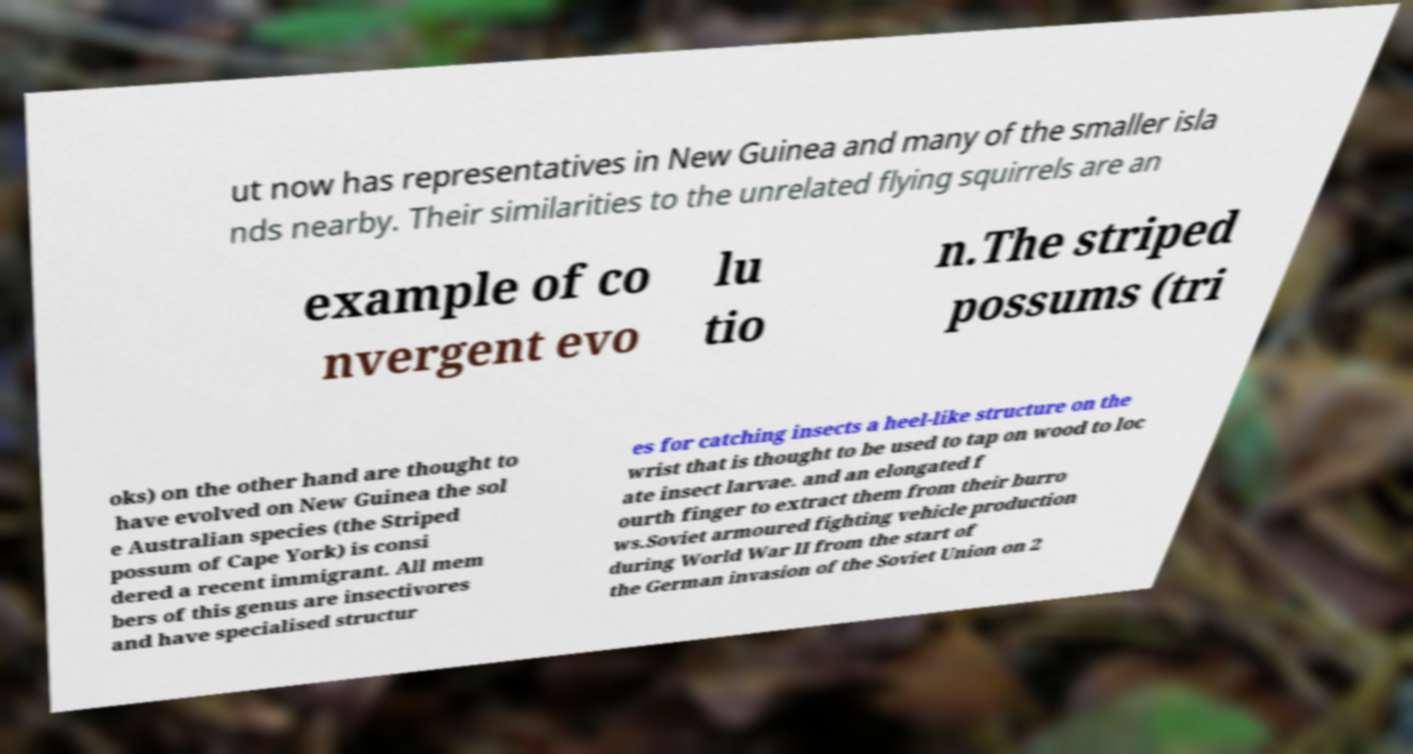Can you read and provide the text displayed in the image?This photo seems to have some interesting text. Can you extract and type it out for me? ut now has representatives in New Guinea and many of the smaller isla nds nearby. Their similarities to the unrelated flying squirrels are an example of co nvergent evo lu tio n.The striped possums (tri oks) on the other hand are thought to have evolved on New Guinea the sol e Australian species (the Striped possum of Cape York) is consi dered a recent immigrant. All mem bers of this genus are insectivores and have specialised structur es for catching insects a heel-like structure on the wrist that is thought to be used to tap on wood to loc ate insect larvae. and an elongated f ourth finger to extract them from their burro ws.Soviet armoured fighting vehicle production during World War II from the start of the German invasion of the Soviet Union on 2 